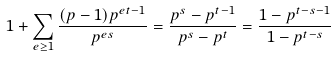Convert formula to latex. <formula><loc_0><loc_0><loc_500><loc_500>1 + \sum _ { e \geq 1 } \frac { ( p - 1 ) p ^ { e t - 1 } } { p ^ { e s } } = \frac { p ^ { s } - p ^ { t - 1 } } { p ^ { s } - p ^ { t } } = \frac { 1 - p ^ { t - s - 1 } } { 1 - p ^ { t - s } }</formula> 